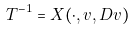Convert formula to latex. <formula><loc_0><loc_0><loc_500><loc_500>T ^ { - 1 } = X ( \cdot , v , D v )</formula> 